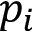Convert formula to latex. <formula><loc_0><loc_0><loc_500><loc_500>p _ { i }</formula> 